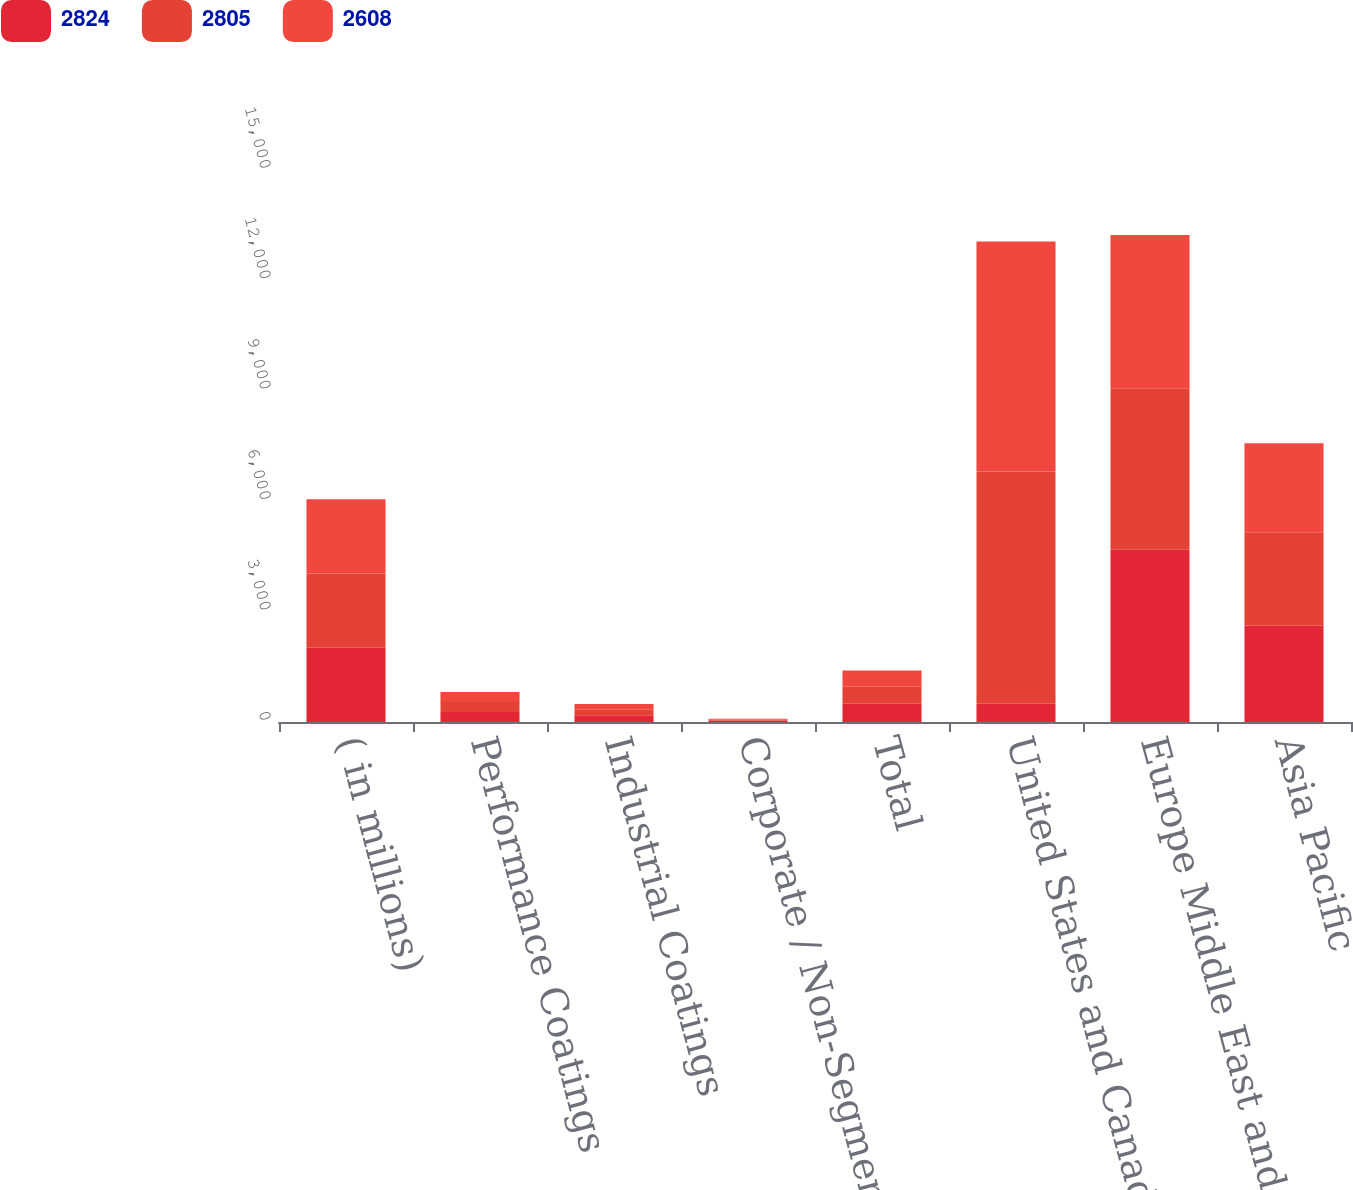Convert chart. <chart><loc_0><loc_0><loc_500><loc_500><stacked_bar_chart><ecel><fcel>( in millions)<fcel>Performance Coatings<fcel>Industrial Coatings<fcel>Corporate / Non-Segment Items<fcel>Total<fcel>United States and Canada<fcel>Europe Middle East and Africa<fcel>Asia Pacific<nl><fcel>2824<fcel>2018<fcel>274<fcel>181<fcel>42<fcel>497<fcel>497<fcel>4678<fcel>2618<nl><fcel>2805<fcel>2017<fcel>272<fcel>164<fcel>24<fcel>460<fcel>6307<fcel>4389<fcel>2523<nl><fcel>2608<fcel>2016<fcel>272<fcel>143<fcel>25<fcel>440<fcel>6254<fcel>4164<fcel>2431<nl></chart> 